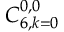<formula> <loc_0><loc_0><loc_500><loc_500>C _ { 6 , k = 0 } ^ { 0 , 0 }</formula> 